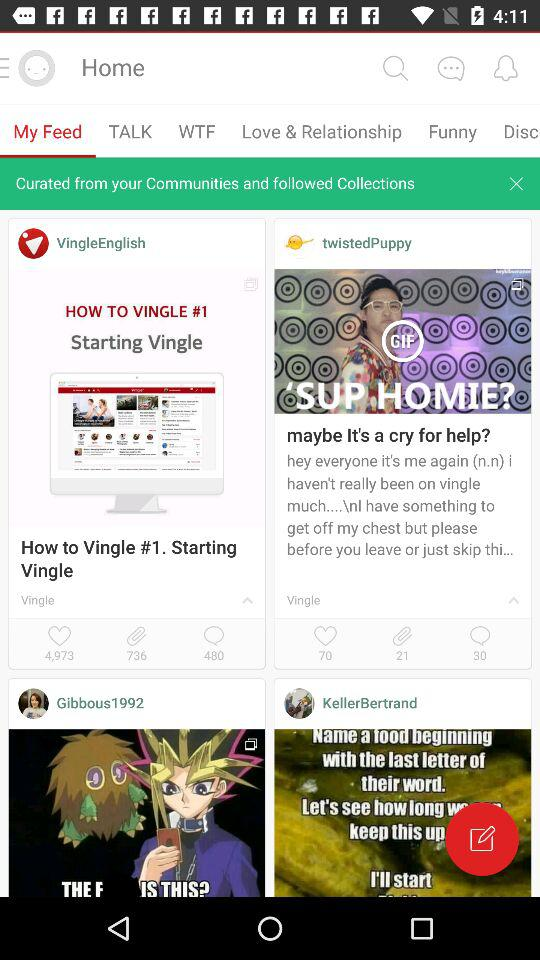How many likes are there for "twistedPuppy"? There are 70 likes. 